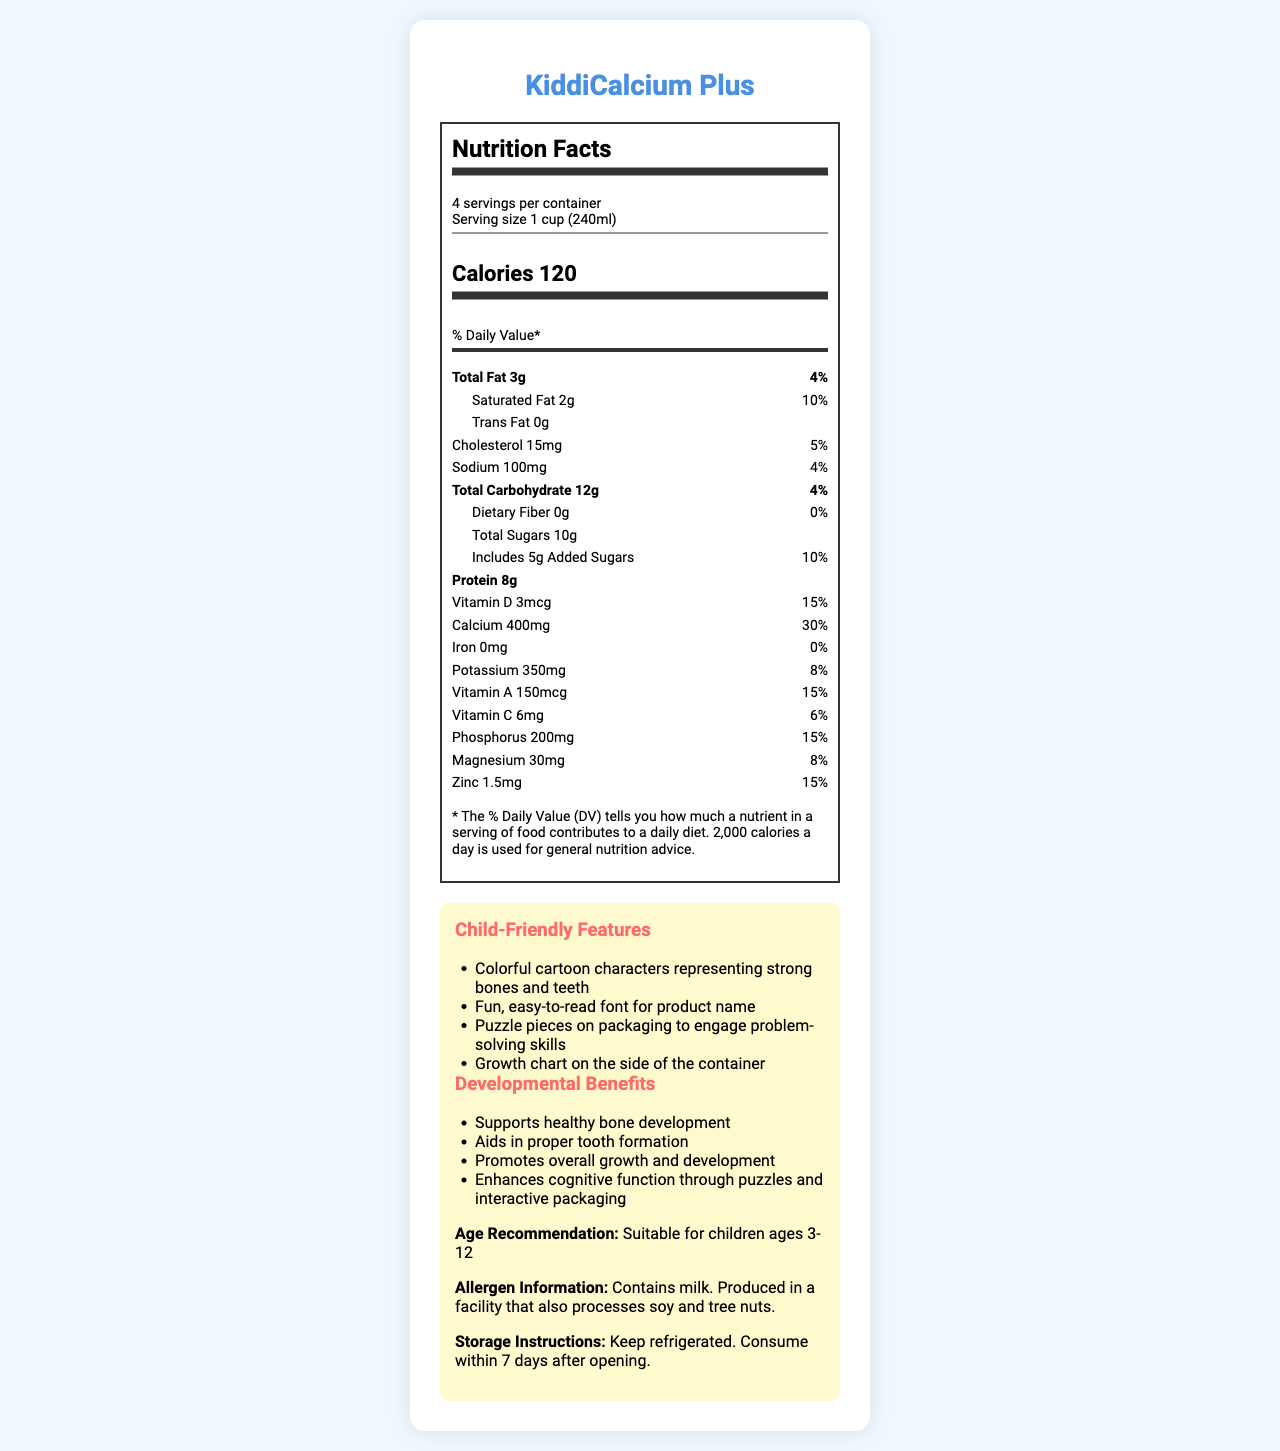What is the serving size for KiddiCalcium Plus? The serving size is clearly specified in the nutrition facts section.
Answer: 1 cup (240ml) How many calories are in one serving of KiddiCalcium Plus? The number of calories per serving is listed under the main nutrition facts header.
Answer: 120 calories What percentage of the daily value of calcium does one serving provide? The daily value percentage for calcium is listed in the nutrition facts section.
Answer: 30% Is there any iron in KiddiCalcium Plus? The iron content is listed as 0mg with a 0% daily value.
Answer: No How much protein does one serving of KiddiCalcium Plus contain? The amount of protein is given in the nutrition facts as 8 grams.
Answer: 8g Which nutrient listed provides the highest percentage of the daily value? A. Vitamin D B. Calcium C. Potassium D. Vitamin C Calcium provides 30% of the daily value, the highest percentage among the listed nutrients.
Answer: B. Calcium Which child-friendly feature is specifically designed to engage cognitive functions? A. Colorful cartoon characters B. Fun, easy-to-read font C. Puzzle pieces on packaging D. Growth chart on the container The puzzle pieces on the packaging are mentioned to engage problem-solving skills, enhancing cognitive function.
Answer: C. Puzzle pieces on packaging Does KiddiCalcium Plus contain added sugars? The nutrition facts mention that one serving includes 5g of added sugars.
Answer: Yes Is KiddiCalcium Plus suitable for children with nut allergies? The allergen information states that it contains milk and is produced in a facility that processes soy and tree nuts.
Answer: No Summarize the key information presented in the document. The document describes both the nutritional content and the child-friendly and developmental benefits of KiddiCalcium Plus. It highlights the product's suitability, nutrient composition, and engaging packaging features. There are allergen warnings and storage instructions provided as well.
Answer: KiddiCalcium Plus is a calcium-rich dairy product designed for children ages 3-12. It provides important nutrients like calcium, protein, and vitamins to support healthy bone development, tooth formation, and overall growth. It contains 120 calories per serving, with 30% of the daily value for calcium. The packaging includes child-friendly features to engage cognitive functions and monitor growth. However, it contains milk and is produced in a facility that processes soy and tree nuts. How is KiddiCalcium Plus recommended to be stored? The storage instructions are explicitly mentioned under the child-friendly features.
Answer: Keep refrigerated. Consume within 7 days after opening. What is the main benefit of the colorful cartoon characters on the package? The colorful cartoon characters are intended to represent strong bones and teeth, which aligns with the product’s benefits.
Answer: Representing strong bones and teeth How many grams of saturated fat does one serving contain? The amount of saturated fat is listed as 2 grams in the nutrition facts.
Answer: 2g What are the developmental benefits of KiddiCalcium Plus? The developmental benefits are clearly outlined in the child-friendly features section.
Answer: Supports healthy bone development, aids in proper tooth formation, promotes overall growth and development, enhances cognitive function through puzzles and interactive packaging. What is the price of KiddiCalcium Plus? The price information is not provided in the document.
Answer: Cannot be determined 